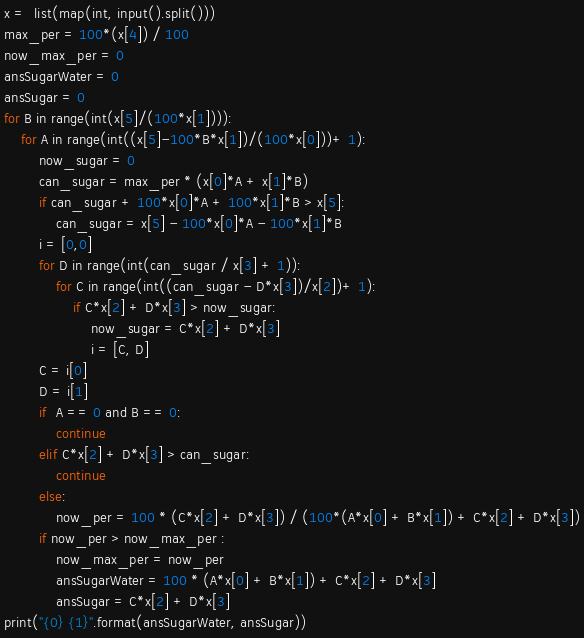Convert code to text. <code><loc_0><loc_0><loc_500><loc_500><_Python_>x =  list(map(int, input().split()))
max_per = 100*(x[4]) / 100
now_max_per = 0
ansSugarWater = 0
ansSugar = 0
for B in range(int(x[5]/(100*x[1]))):
    for A in range(int((x[5]-100*B*x[1])/(100*x[0]))+ 1):
        now_sugar = 0
        can_sugar = max_per * (x[0]*A + x[1]*B)
        if can_sugar + 100*x[0]*A + 100*x[1]*B > x[5]:
            can_sugar = x[5] - 100*x[0]*A - 100*x[1]*B
        i = [0,0]
        for D in range(int(can_sugar / x[3] + 1)):
            for C in range(int((can_sugar - D*x[3])/x[2])+ 1):
                if C*x[2] + D*x[3] > now_sugar:
                    now_sugar = C*x[2] + D*x[3]
                    i = [C, D]
        C = i[0]
        D = i[1]
        if  A == 0 and B == 0:
            continue
        elif C*x[2] + D*x[3] > can_sugar:
            continue
        else:
            now_per = 100 * (C*x[2] + D*x[3]) / (100*(A*x[0] + B*x[1]) + C*x[2] + D*x[3])
        if now_per > now_max_per :
            now_max_per = now_per
            ansSugarWater = 100 * (A*x[0] + B*x[1]) + C*x[2] + D*x[3]
            ansSugar = C*x[2] + D*x[3]
print("{0} {1}".format(ansSugarWater, ansSugar))</code> 